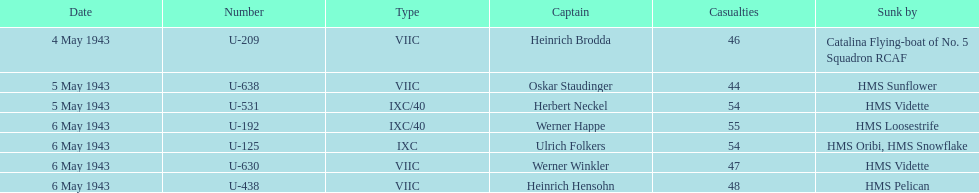Which u-boat had the greatest number of casualties when it sank? U-192. 